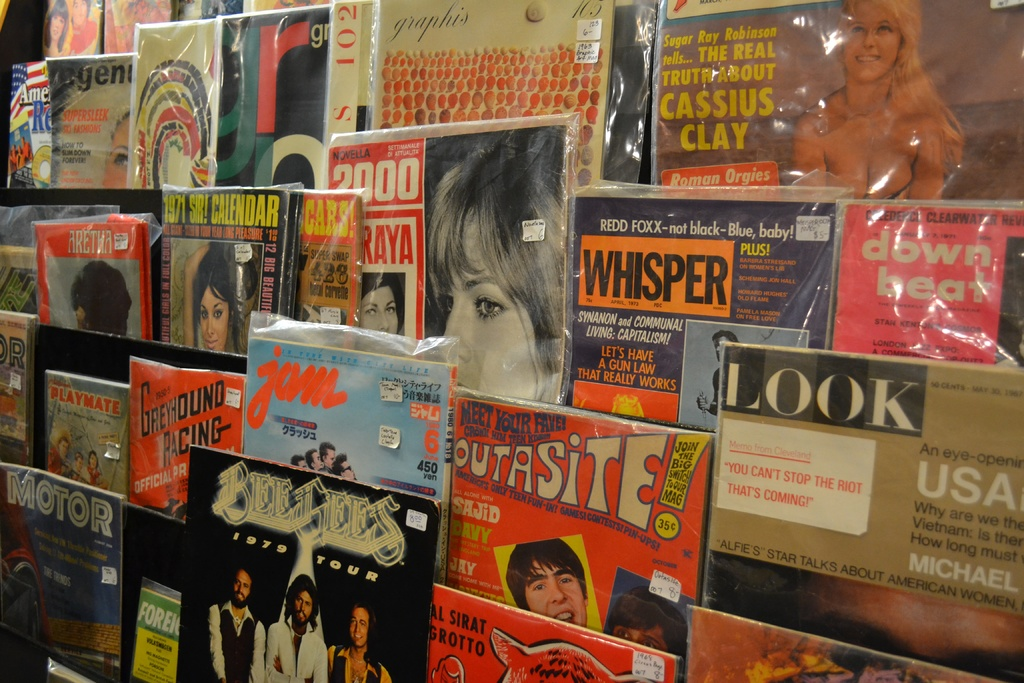What types of themes are prevalent in the magazines shown in this image? The magazines in the image display a variety of themes including pop culture, music, sports like greyhound racing, strategic guides for communal living, and provocative celebrity tales, offering a snapshot of the cultural and social currents of their publication periods. 